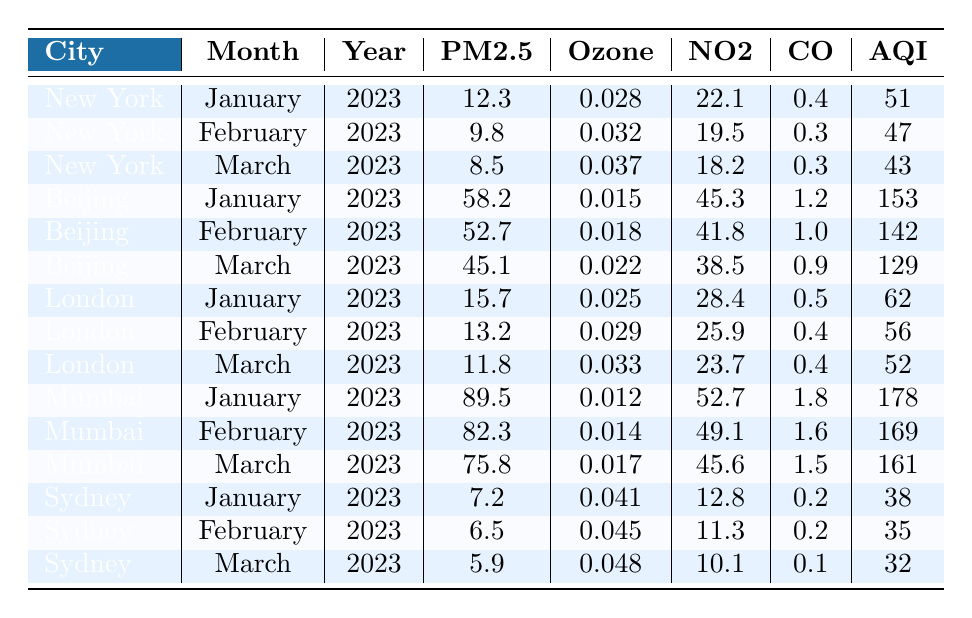What is the AQI value for Mumbai in March 2023? According to the table, the AQI value for Mumbai in March 2023 is directly provided in the corresponding row. Looking at the India row for March, we find the AQI is 161.
Answer: 161 What was the PM2.5 measurement for New York in January 2023? The table has a specific row for New York in January 2023, which shows the PM2.5 measurement is 12.3.
Answer: 12.3 Which city had the highest CO level in January 2023? By examining the CO values for each city listed for January 2023, we see that Mumbai has a CO level of 1.8, which is higher than any other city.
Answer: Mumbai Is the AQI for Sydney in February higher than that in January? The AQI for Sydney in February 2023 is 35, while in January it is 38. Since 35 is less than 38, the statement is false.
Answer: No What is the average PM2.5 level across all cities for February 2023? The PM2.5 levels for February 2023 from all cities are 9.8 (New York), 52.7 (Beijing), 13.2 (London), 82.3 (Mumbai), and 6.5 (Sydney). The sum is 9.8 + 52.7 + 13.2 + 82.3 + 6.5 = 164.5, and dividing by the number of cities (5) gives an average of 32.9.
Answer: 32.9 Which city shows the greatest decrease in AQI from January to March 2023? To find this, we need to check the AQI for each city in January (Mumbai: 178, Beijing: 153, New York: 51, London: 62, Sydney: 38) and March (Mumbai: 161, Beijing: 129, New York: 43, London: 52, Sydney: 32). The decreases are: Mumbai (-17), Beijing (-24), New York (-8), London (-10), and Sydney (-6). The greatest decrease is in Beijing with -24.
Answer: Beijing What is the average AQI in January 2023 for all the cities listed? The AQI values for January 2023 are 51 (New York), 153 (Beijing), 62 (London), 178 (Mumbai), and 38 (Sydney). Summing these yields 51 + 153 + 62 + 178 + 38 = 482, and dividing by the number of cities (5) results in an average AQI of 96.4.
Answer: 96.4 Did New York ever exceed an AQI of 50 during the months listed? The AQI values for New York in January, February, and March 2023 are 51, 47, and 43, respectively. Since January's AQI (51) is over the threshold of 50, the answer is yes.
Answer: Yes What is the trend of PM2.5 values for Sydney over the three months? The PM2.5 values for Sydney in January, February, and March 2023 are 7.2, 6.5, and 5.9 respectively. The values show a decreasing trend as they drop each month.
Answer: Decreasing 